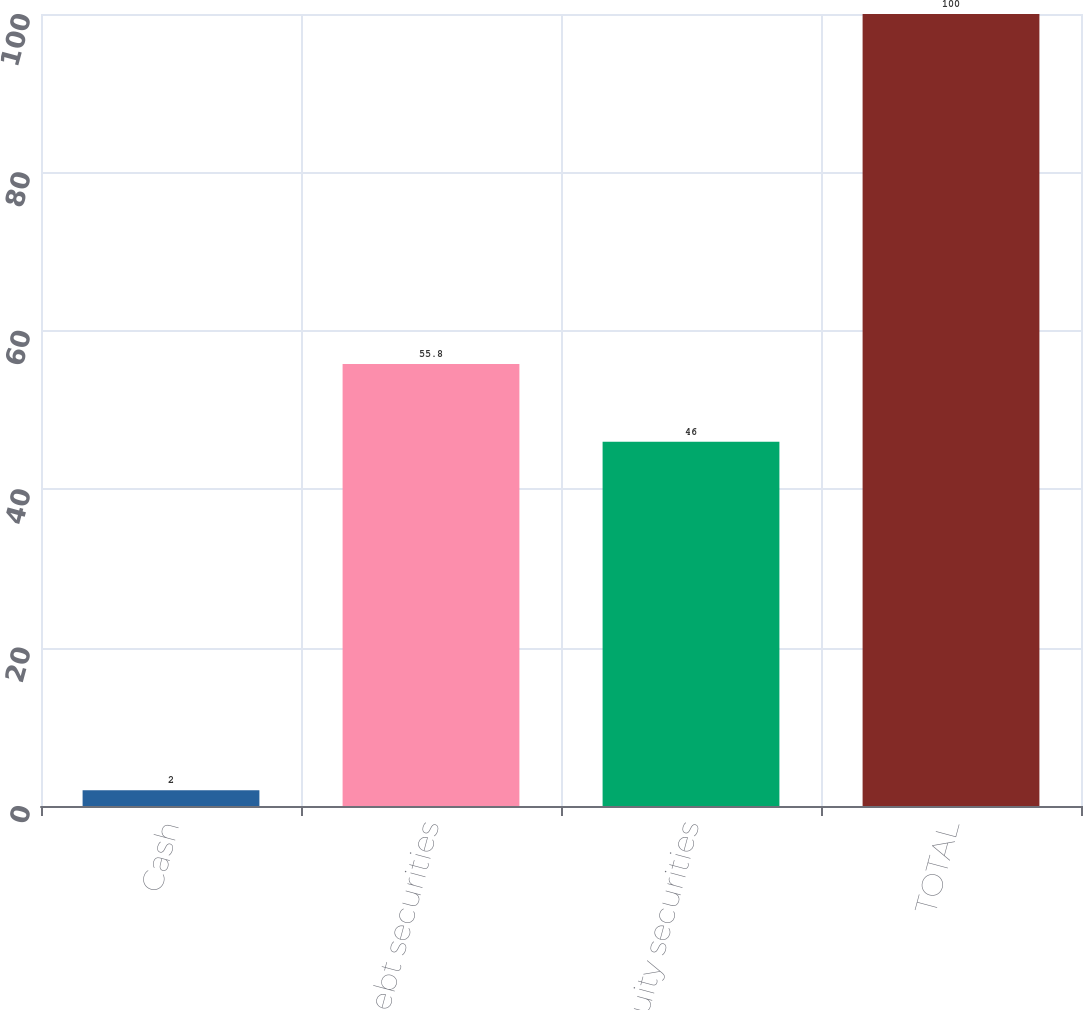Convert chart. <chart><loc_0><loc_0><loc_500><loc_500><bar_chart><fcel>Cash<fcel>Debt securities<fcel>Equity securities<fcel>TOTAL<nl><fcel>2<fcel>55.8<fcel>46<fcel>100<nl></chart> 